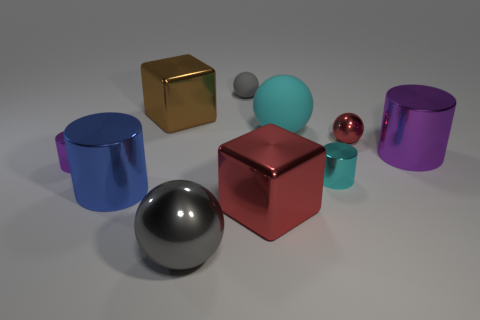Is the size of the red sphere the same as the purple cylinder that is to the left of the tiny gray matte thing?
Provide a short and direct response. Yes. There is a big cylinder right of the small sphere that is in front of the big cyan rubber thing; what is it made of?
Your response must be concise. Metal. What size is the red metallic object that is right of the big cube in front of the big cylinder in front of the large purple metal cylinder?
Give a very brief answer. Small. There is a large red thing; is it the same shape as the metallic thing that is behind the red ball?
Give a very brief answer. Yes. What is the brown cube made of?
Your answer should be very brief. Metal. What number of rubber objects are either big blue things or big yellow balls?
Your response must be concise. 0. Are there fewer gray matte objects in front of the cyan matte object than cyan cylinders in front of the big blue metal object?
Keep it short and to the point. No. Is there a rubber thing in front of the big brown shiny object behind the metallic object that is to the right of the small red ball?
Make the answer very short. Yes. There is a object that is the same color as the big shiny sphere; what is it made of?
Your answer should be compact. Rubber. Does the gray object in front of the red ball have the same shape as the gray object behind the blue cylinder?
Provide a succinct answer. Yes. 